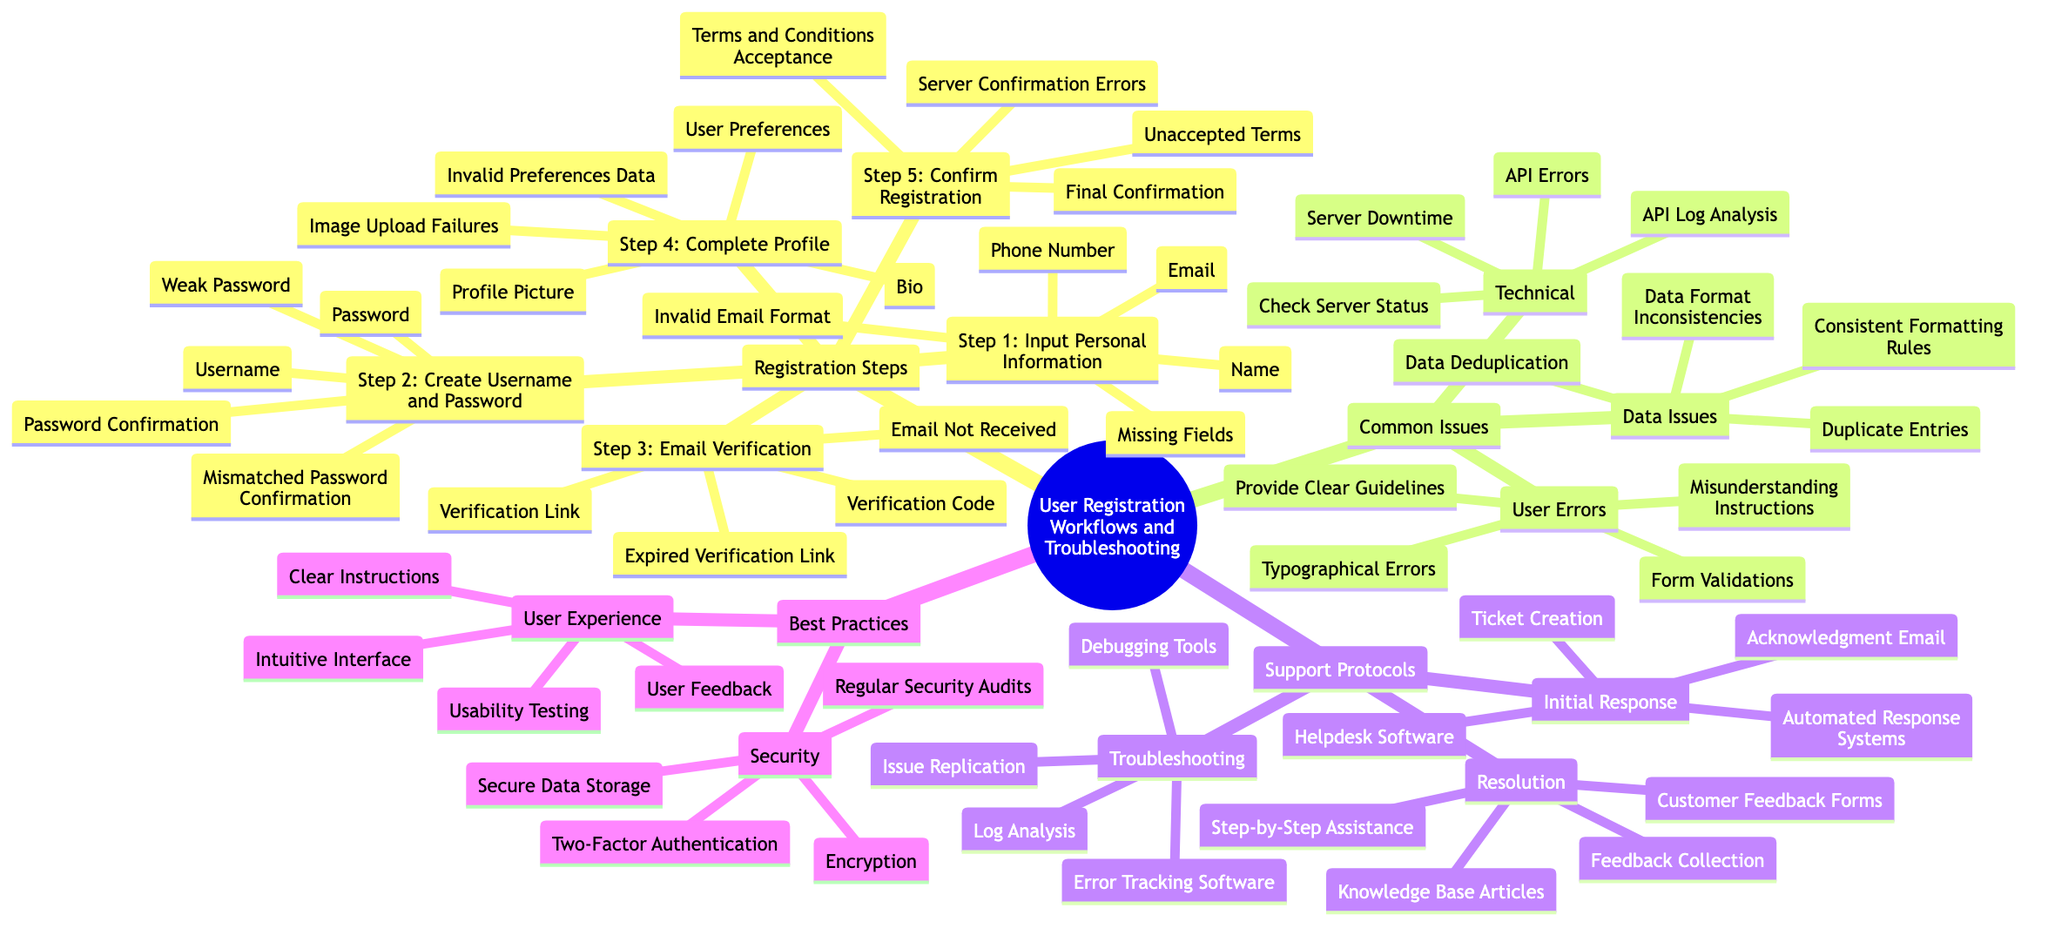What's the first step in the registration workflow? The diagram outlines a series of steps in a user registration workflow, starting with "Step 1: Input Personal Information." This is the first node under the Registration Steps category.
Answer: Step 1: Input Personal Information How many elements are in Step 2? In Step 2, which focuses on creating a username and password, there are three listed elements: Username, Password, and Password Confirmation. A count of these elements gives the number.
Answer: 3 What issues are listed for Email Verification? The diagram shows two specific issues under Step 3, Email Verification: "Email Not Received" and "Expired Verification Link." These are the identified problems at this stage of the workflow.
Answer: Email Not Received, Expired Verification Link Which best practice method enhances user experience? Under the Best Practices section for User Experience, one method mentioned is "Usability Testing." This method is aimed at improving the user's interaction with the interface.
Answer: Usability Testing What is the tool used for initial response according to the support protocols? The diagram specifies "Helpdesk Software" as one of the tools used in the Initial Response protocol under Support Protocols. This software assists in effectively managing customer queries.
Answer: Helpdesk Software What does the Data Issues section suggest for dealing with duplicate entries? The diagram indicates that the solution for addressing duplicate entries under Data Issues is "Data Deduplication," which aims to remove unnecessary repeated data entries.
Answer: Data Deduplication How many issues are associated with Step 4: Complete Profile? In Step 4, there are two issues listed: "Image Upload Failures" and "Invalid Preferences Data." Therefore, the total count of issues here is two.
Answer: 2 Which security method is mentioned for protecting data? In discussing security under Best Practices, the diagram cites "Encryption" as a method to protect data, ensuring that information is kept secure from unauthorized access.
Answer: Encryption What tool is used for log analysis in the troubleshooting phase? The diagram specifies "Error Tracking Software" as one of the tools utilized for log analysis during the Troubleshooting phase, indicating its importance in identifying and resolving issues.
Answer: Error Tracking Software 